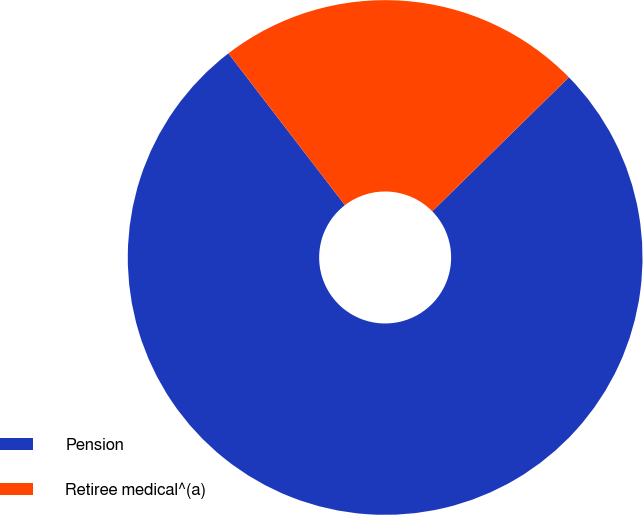<chart> <loc_0><loc_0><loc_500><loc_500><pie_chart><fcel>Pension<fcel>Retiree medical^(a)<nl><fcel>76.92%<fcel>23.08%<nl></chart> 